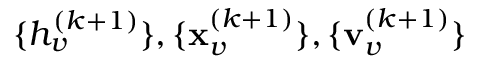Convert formula to latex. <formula><loc_0><loc_0><loc_500><loc_500>\{ h _ { v } ^ { ( k + 1 ) } \} , \{ x _ { v } ^ { ( k + 1 ) } \} , \{ v _ { v } ^ { ( k + 1 ) } \}</formula> 